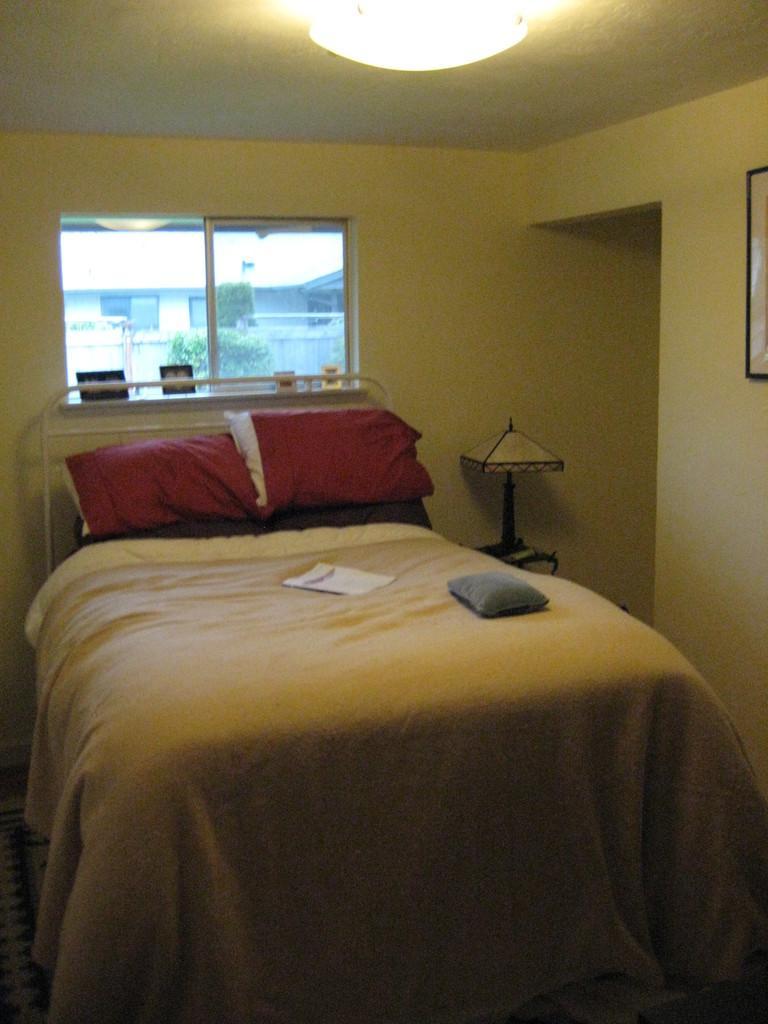In one or two sentences, can you explain what this image depicts? In this picture we can see a bed in the front, there are two pillows and a bed sheet on the bed, we can see a lamp here, in the background there is a window, we can see a tree from the window. 